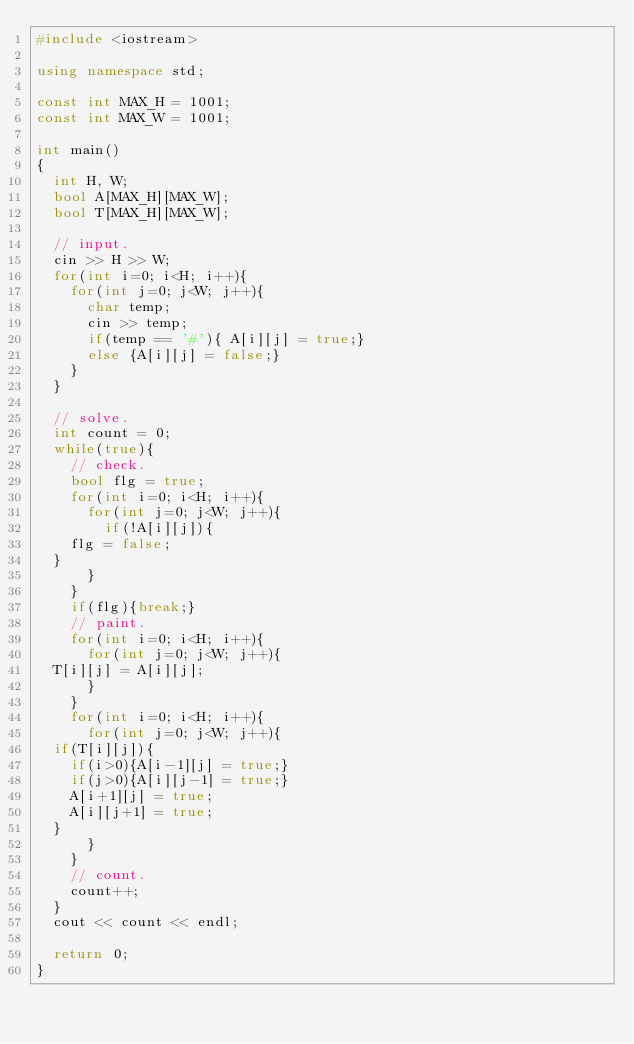<code> <loc_0><loc_0><loc_500><loc_500><_C++_>#include <iostream>

using namespace std;

const int MAX_H = 1001;
const int MAX_W = 1001;

int main()
{
  int H, W;
  bool A[MAX_H][MAX_W];
  bool T[MAX_H][MAX_W];

  // input. 
  cin >> H >> W;
  for(int i=0; i<H; i++){
    for(int j=0; j<W; j++){
      char temp;
      cin >> temp;
      if(temp == '#'){ A[i][j] = true;}
      else {A[i][j] = false;}
    }
  }
  
  // solve.
  int count = 0;
  while(true){
    // check. 
    bool flg = true;
    for(int i=0; i<H; i++){
      for(int j=0; j<W; j++){
        if(!A[i][j]){
	  flg = false;
	}
      }
    }
    if(flg){break;}
    // paint. 
    for(int i=0; i<H; i++){
      for(int j=0; j<W; j++){
	T[i][j] = A[i][j];
      }
    }
    for(int i=0; i<H; i++){
      for(int j=0; j<W; j++){
	if(T[i][j]){
	  if(i>0){A[i-1][j] = true;}
	  if(j>0){A[i][j-1] = true;}
	  A[i+1][j] = true;
	  A[i][j+1] = true;
	}   
      }
    }
    // count. 
    count++;
  }
  cout << count << endl;
  
  return 0;
}
</code> 